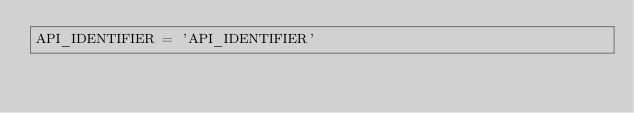<code> <loc_0><loc_0><loc_500><loc_500><_Python_>API_IDENTIFIER = 'API_IDENTIFIER'
</code> 